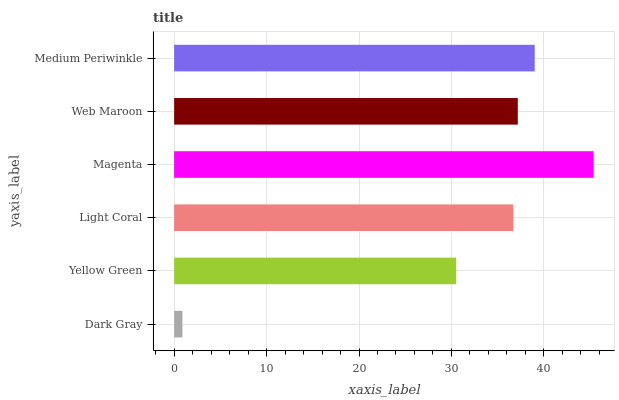Is Dark Gray the minimum?
Answer yes or no. Yes. Is Magenta the maximum?
Answer yes or no. Yes. Is Yellow Green the minimum?
Answer yes or no. No. Is Yellow Green the maximum?
Answer yes or no. No. Is Yellow Green greater than Dark Gray?
Answer yes or no. Yes. Is Dark Gray less than Yellow Green?
Answer yes or no. Yes. Is Dark Gray greater than Yellow Green?
Answer yes or no. No. Is Yellow Green less than Dark Gray?
Answer yes or no. No. Is Web Maroon the high median?
Answer yes or no. Yes. Is Light Coral the low median?
Answer yes or no. Yes. Is Yellow Green the high median?
Answer yes or no. No. Is Web Maroon the low median?
Answer yes or no. No. 